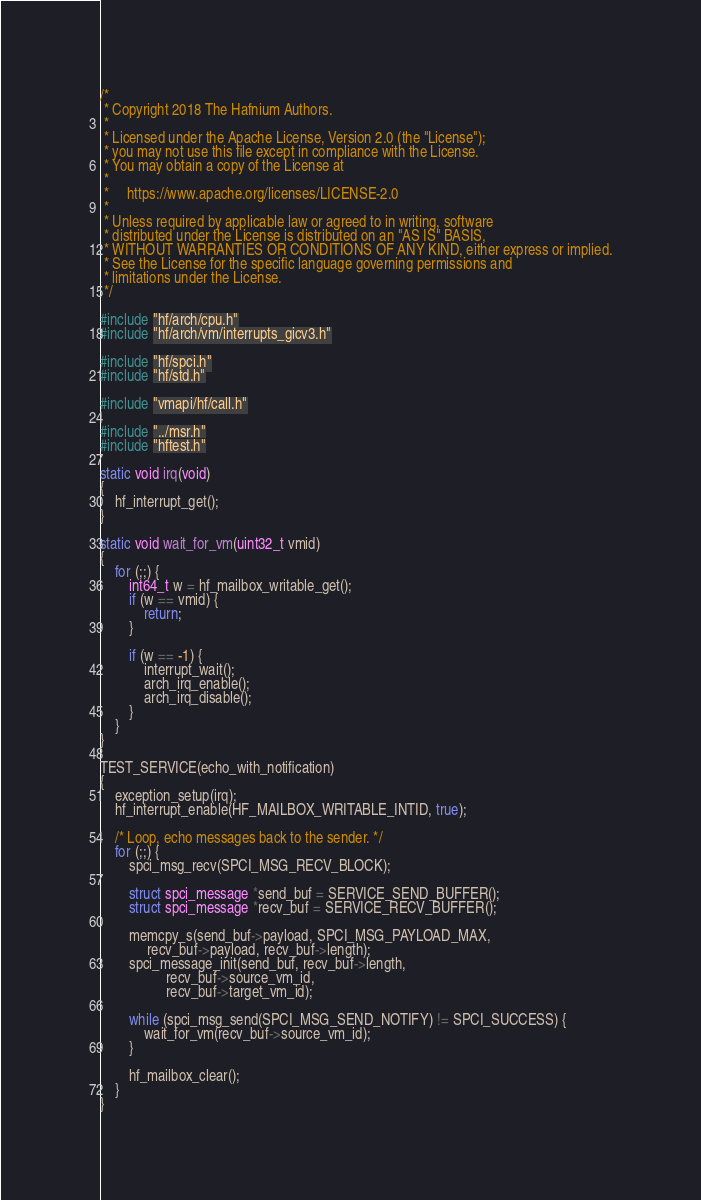<code> <loc_0><loc_0><loc_500><loc_500><_C_>/*
 * Copyright 2018 The Hafnium Authors.
 *
 * Licensed under the Apache License, Version 2.0 (the "License");
 * you may not use this file except in compliance with the License.
 * You may obtain a copy of the License at
 *
 *     https://www.apache.org/licenses/LICENSE-2.0
 *
 * Unless required by applicable law or agreed to in writing, software
 * distributed under the License is distributed on an "AS IS" BASIS,
 * WITHOUT WARRANTIES OR CONDITIONS OF ANY KIND, either express or implied.
 * See the License for the specific language governing permissions and
 * limitations under the License.
 */

#include "hf/arch/cpu.h"
#include "hf/arch/vm/interrupts_gicv3.h"

#include "hf/spci.h"
#include "hf/std.h"

#include "vmapi/hf/call.h"

#include "../msr.h"
#include "hftest.h"

static void irq(void)
{
	hf_interrupt_get();
}

static void wait_for_vm(uint32_t vmid)
{
	for (;;) {
		int64_t w = hf_mailbox_writable_get();
		if (w == vmid) {
			return;
		}

		if (w == -1) {
			interrupt_wait();
			arch_irq_enable();
			arch_irq_disable();
		}
	}
}

TEST_SERVICE(echo_with_notification)
{
	exception_setup(irq);
	hf_interrupt_enable(HF_MAILBOX_WRITABLE_INTID, true);

	/* Loop, echo messages back to the sender. */
	for (;;) {
		spci_msg_recv(SPCI_MSG_RECV_BLOCK);

		struct spci_message *send_buf = SERVICE_SEND_BUFFER();
		struct spci_message *recv_buf = SERVICE_RECV_BUFFER();

		memcpy_s(send_buf->payload, SPCI_MSG_PAYLOAD_MAX,
			 recv_buf->payload, recv_buf->length);
		spci_message_init(send_buf, recv_buf->length,
				  recv_buf->source_vm_id,
				  recv_buf->target_vm_id);

		while (spci_msg_send(SPCI_MSG_SEND_NOTIFY) != SPCI_SUCCESS) {
			wait_for_vm(recv_buf->source_vm_id);
		}

		hf_mailbox_clear();
	}
}
</code> 